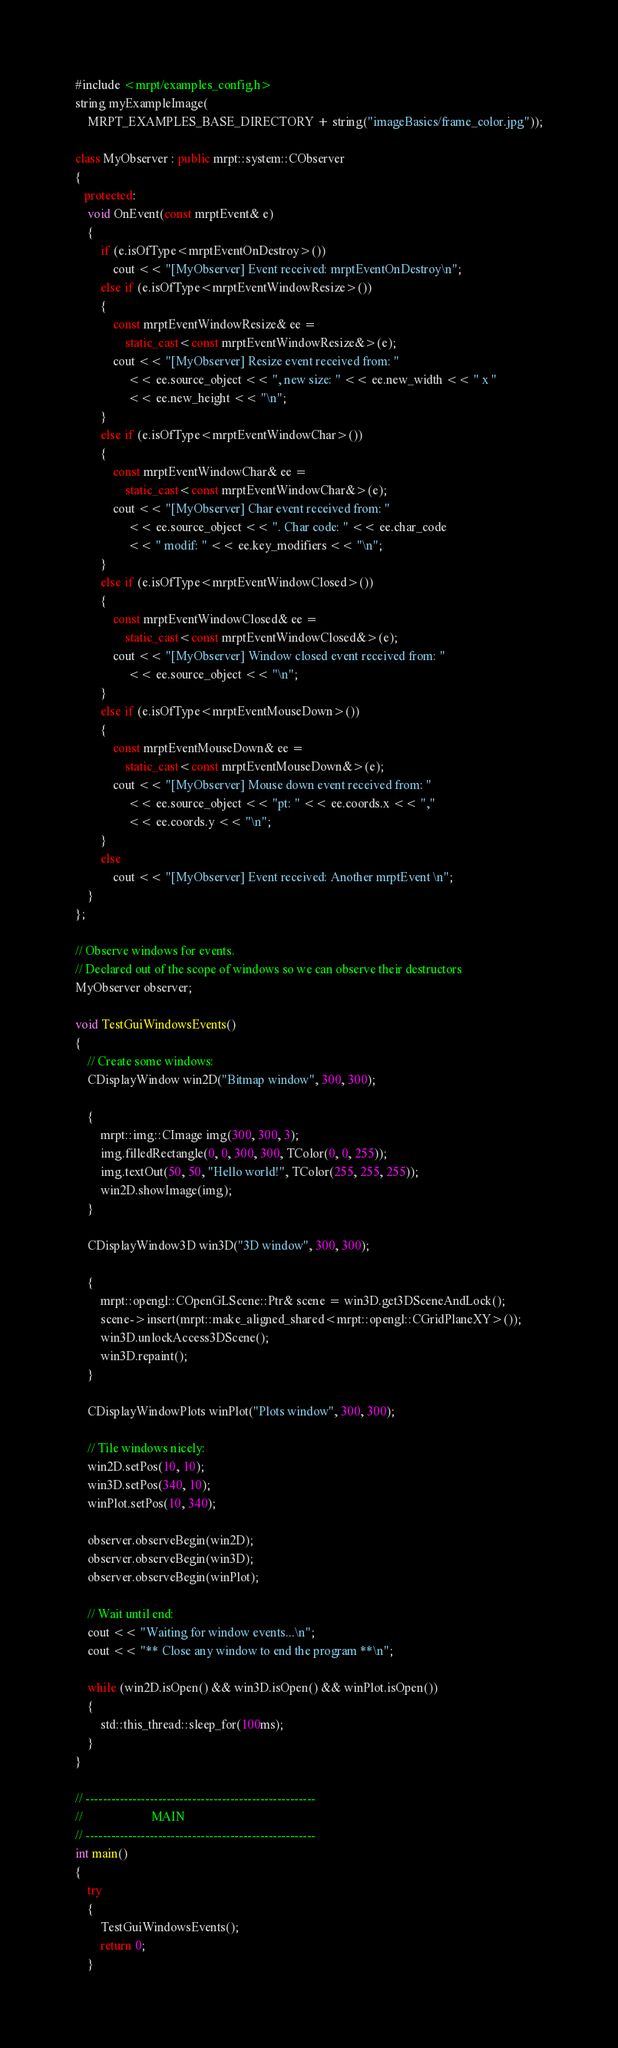<code> <loc_0><loc_0><loc_500><loc_500><_C++_>#include <mrpt/examples_config.h>
string myExampleImage(
	MRPT_EXAMPLES_BASE_DIRECTORY + string("imageBasics/frame_color.jpg"));

class MyObserver : public mrpt::system::CObserver
{
   protected:
	void OnEvent(const mrptEvent& e)
	{
		if (e.isOfType<mrptEventOnDestroy>())
			cout << "[MyObserver] Event received: mrptEventOnDestroy\n";
		else if (e.isOfType<mrptEventWindowResize>())
		{
			const mrptEventWindowResize& ee =
				static_cast<const mrptEventWindowResize&>(e);
			cout << "[MyObserver] Resize event received from: "
				 << ee.source_object << ", new size: " << ee.new_width << " x "
				 << ee.new_height << "\n";
		}
		else if (e.isOfType<mrptEventWindowChar>())
		{
			const mrptEventWindowChar& ee =
				static_cast<const mrptEventWindowChar&>(e);
			cout << "[MyObserver] Char event received from: "
				 << ee.source_object << ". Char code: " << ee.char_code
				 << " modif: " << ee.key_modifiers << "\n";
		}
		else if (e.isOfType<mrptEventWindowClosed>())
		{
			const mrptEventWindowClosed& ee =
				static_cast<const mrptEventWindowClosed&>(e);
			cout << "[MyObserver] Window closed event received from: "
				 << ee.source_object << "\n";
		}
		else if (e.isOfType<mrptEventMouseDown>())
		{
			const mrptEventMouseDown& ee =
				static_cast<const mrptEventMouseDown&>(e);
			cout << "[MyObserver] Mouse down event received from: "
				 << ee.source_object << "pt: " << ee.coords.x << ","
				 << ee.coords.y << "\n";
		}
		else
			cout << "[MyObserver] Event received: Another mrptEvent \n";
	}
};

// Observe windows for events.
// Declared out of the scope of windows so we can observe their destructors
MyObserver observer;

void TestGuiWindowsEvents()
{
	// Create some windows:
	CDisplayWindow win2D("Bitmap window", 300, 300);

	{
		mrpt::img::CImage img(300, 300, 3);
		img.filledRectangle(0, 0, 300, 300, TColor(0, 0, 255));
		img.textOut(50, 50, "Hello world!", TColor(255, 255, 255));
		win2D.showImage(img);
	}

	CDisplayWindow3D win3D("3D window", 300, 300);

	{
		mrpt::opengl::COpenGLScene::Ptr& scene = win3D.get3DSceneAndLock();
		scene->insert(mrpt::make_aligned_shared<mrpt::opengl::CGridPlaneXY>());
		win3D.unlockAccess3DScene();
		win3D.repaint();
	}

	CDisplayWindowPlots winPlot("Plots window", 300, 300);

	// Tile windows nicely:
	win2D.setPos(10, 10);
	win3D.setPos(340, 10);
	winPlot.setPos(10, 340);

	observer.observeBegin(win2D);
	observer.observeBegin(win3D);
	observer.observeBegin(winPlot);

	// Wait until end:
	cout << "Waiting for window events...\n";
	cout << "** Close any window to end the program **\n";

	while (win2D.isOpen() && win3D.isOpen() && winPlot.isOpen())
	{
		std::this_thread::sleep_for(100ms);
	}
}

// ------------------------------------------------------
//						MAIN
// ------------------------------------------------------
int main()
{
	try
	{
		TestGuiWindowsEvents();
		return 0;
	}</code> 